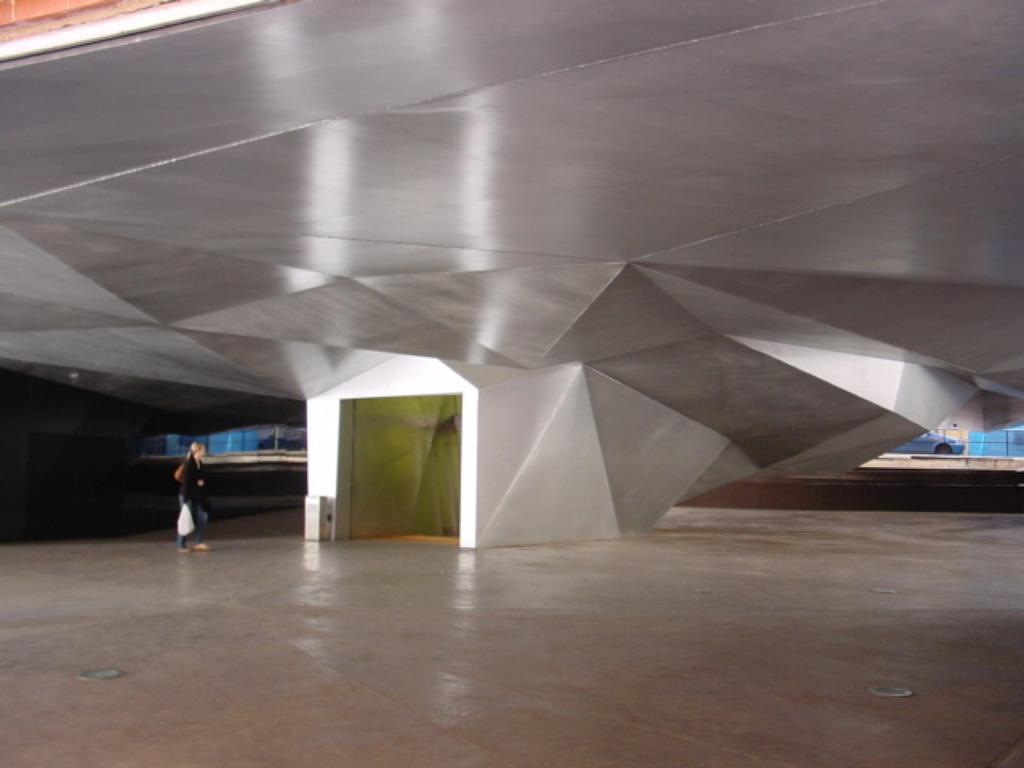What is the person in the image holding? The person is holding a cover bag in the image. What type of roof can be seen in the image? There is an iron roof in the image. What is a feature that allows access to the building or space in the image? There is a door in the image. What can be seen beneath the person's feet in the image? The ground is visible in the image. What mode of transportation is present in the image? There is a vehicle in the image. What type of sound can be heard coming from the vehicle in the image? There is no indication of sound in the image, so it cannot be determined what, if any, sound might be coming from the vehicle. 